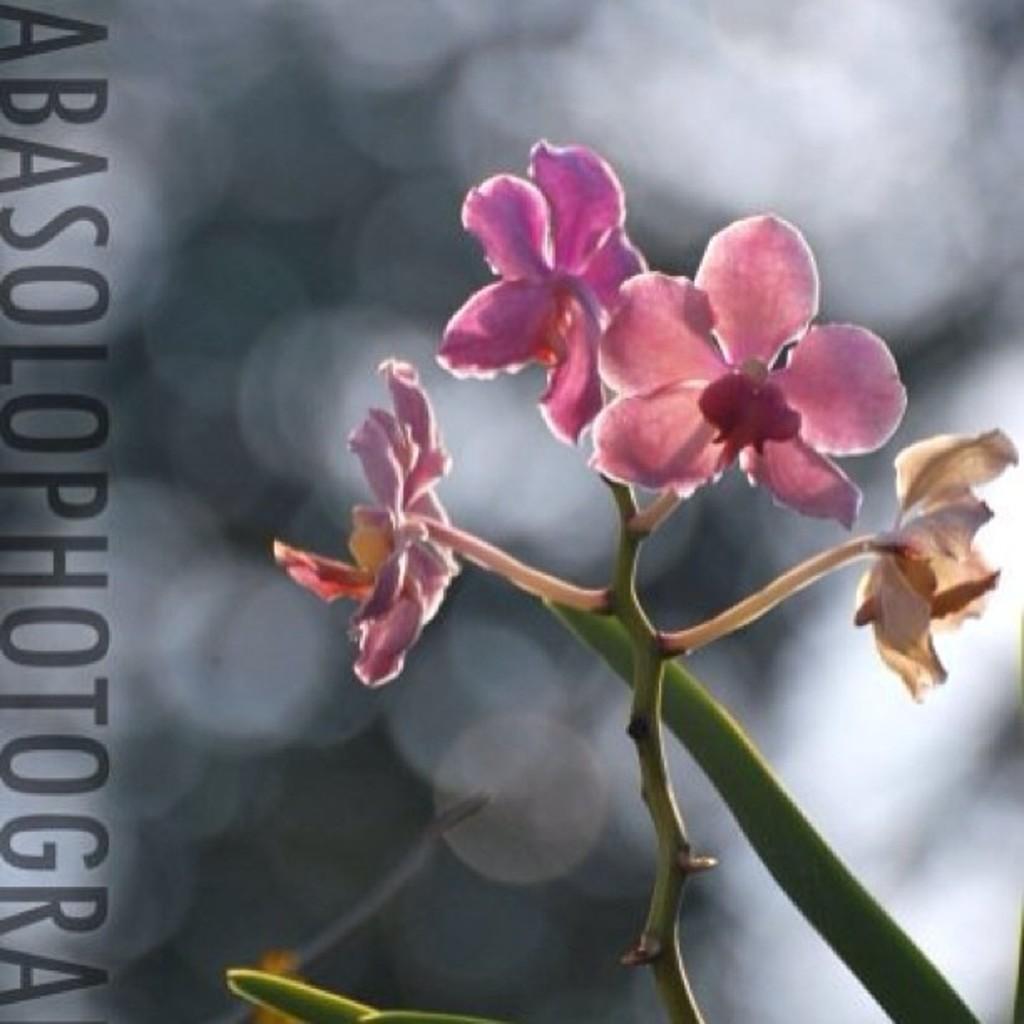Could you give a brief overview of what you see in this image? This image consists of flowers in pink color. At the bottom, there is a plant. The background is blurred To the left, there is a text. 